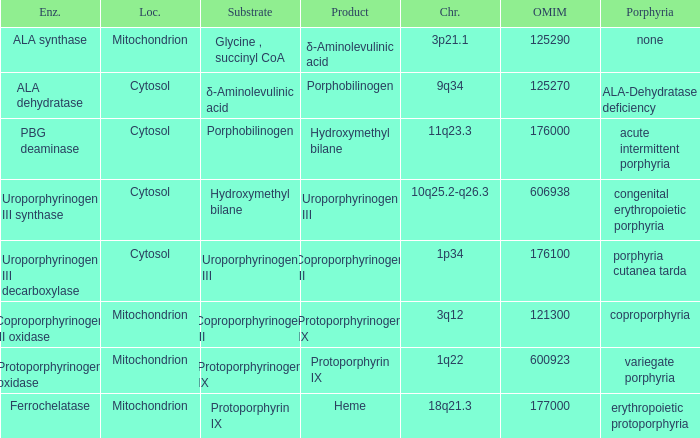What is protoporphyrin ix's substrate? Protoporphyrinogen IX. 